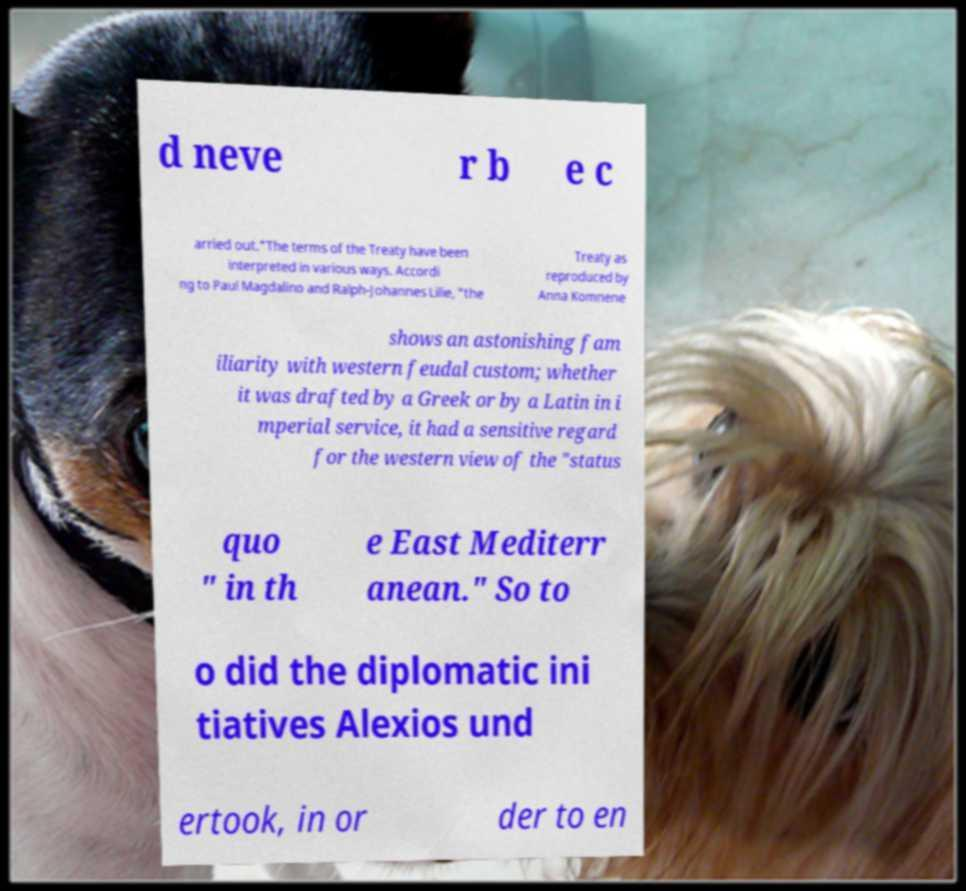For documentation purposes, I need the text within this image transcribed. Could you provide that? d neve r b e c arried out."The terms of the Treaty have been interpreted in various ways. Accordi ng to Paul Magdalino and Ralph-Johannes Lilie, "the Treaty as reproduced by Anna Komnene shows an astonishing fam iliarity with western feudal custom; whether it was drafted by a Greek or by a Latin in i mperial service, it had a sensitive regard for the western view of the "status quo " in th e East Mediterr anean." So to o did the diplomatic ini tiatives Alexios und ertook, in or der to en 